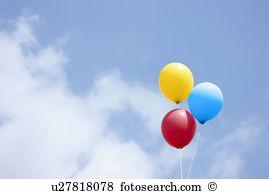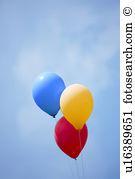The first image is the image on the left, the second image is the image on the right. Considering the images on both sides, is "At least one of the images has a trio of balloons that represent the primary colors." valid? Answer yes or no. Yes. 